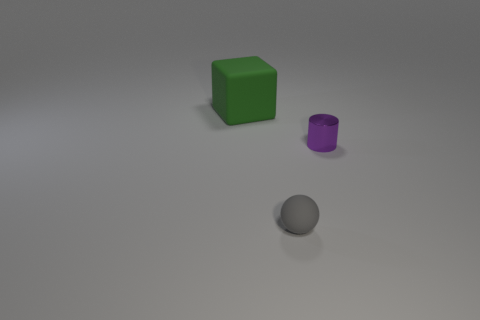Are there any other things that are the same shape as the tiny purple metallic thing?
Keep it short and to the point. No. Are there an equal number of small purple metallic cylinders that are behind the tiny cylinder and green matte objects that are behind the green object?
Your answer should be very brief. Yes. What number of balls are small gray rubber objects or large green metallic objects?
Your answer should be very brief. 1. What number of other things are there of the same material as the tiny gray sphere
Ensure brevity in your answer.  1. There is a matte object right of the block; what is its shape?
Offer a terse response. Sphere. What material is the small object that is on the right side of the rubber object that is to the right of the large rubber thing?
Offer a terse response. Metal. Are there more small gray rubber balls that are behind the big block than purple objects?
Your answer should be very brief. No. What shape is the other thing that is the same size as the gray object?
Provide a succinct answer. Cylinder. How many gray objects are to the right of the thing that is left of the rubber thing right of the green matte thing?
Keep it short and to the point. 1. What number of rubber objects are big cubes or cylinders?
Keep it short and to the point. 1. 